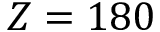Convert formula to latex. <formula><loc_0><loc_0><loc_500><loc_500>Z = 1 8 0</formula> 